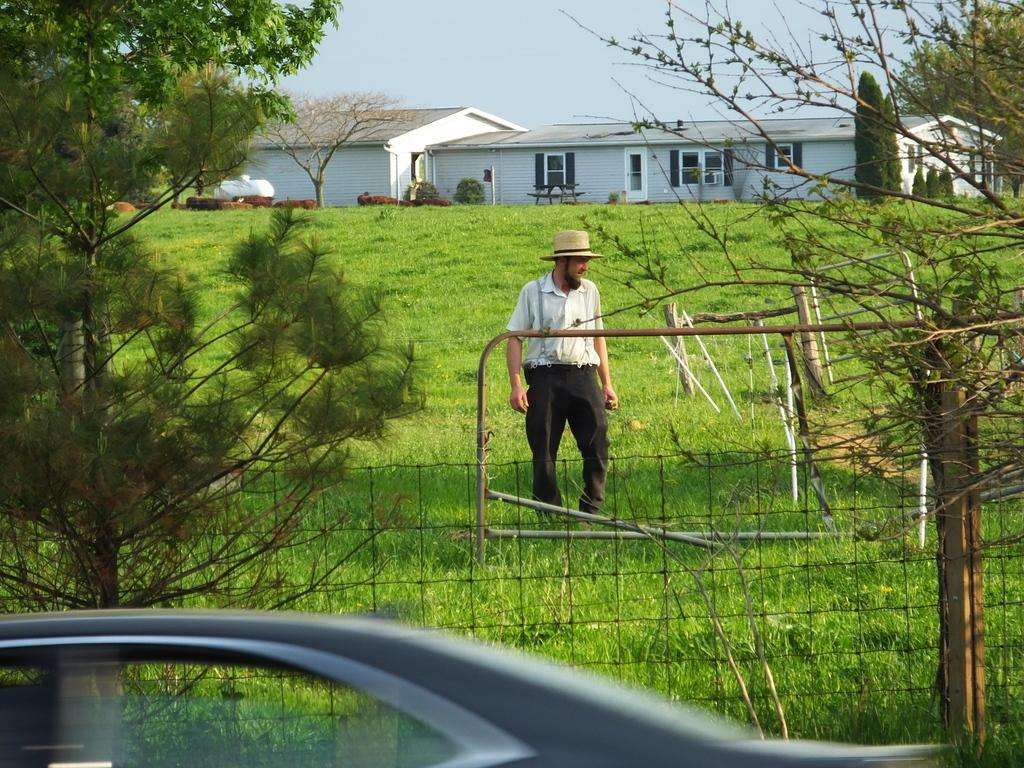What type of structure is present in the image? There is a house in the image. What features can be seen on the house? The house has windows. What type of vegetation is visible in the image? There are trees, grass, and plants in the image. Is there a person in the image? Yes, there is a person in the image. What other objects can be seen in the image? There is a fence, a vehicle, and the sky is visible in the background of the image. Can you tell me how many stamps are on the person's forehead in the image? There are no stamps visible on the person's forehead in the image. What type of animal is ploughing the field in the image? There is no animal ploughing a field in the image; it features a house, trees, grass, plants, a person, a fence, a vehicle, and the sky. 